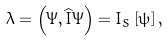Convert formula to latex. <formula><loc_0><loc_0><loc_500><loc_500>\lambda = \left ( \Psi , \widehat { I } \Psi \right ) = I _ { S } \left [ \psi \right ] ,</formula> 